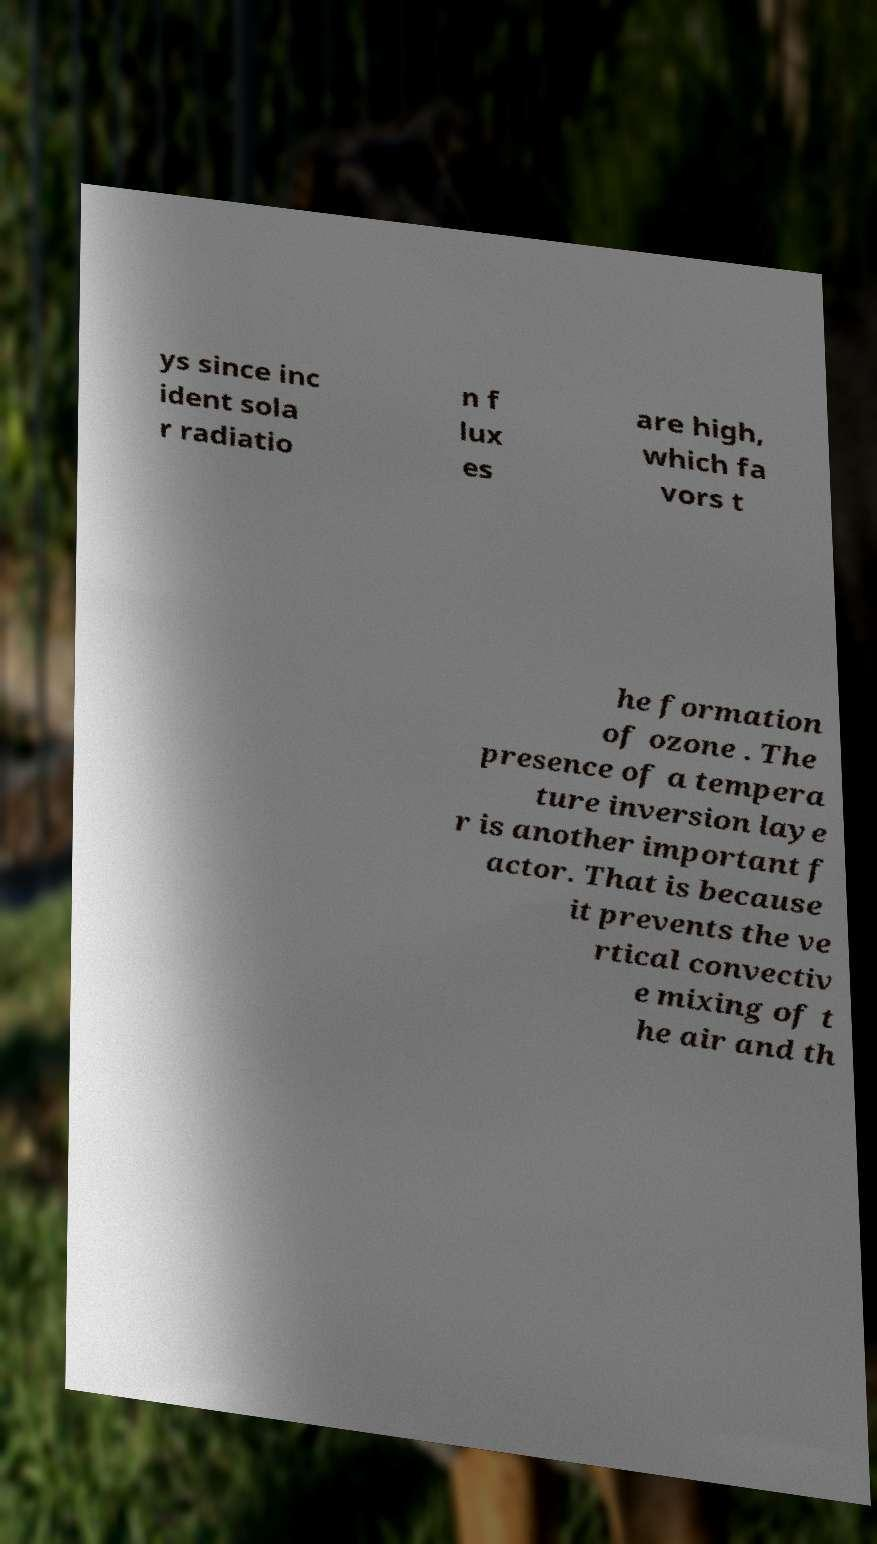Please read and relay the text visible in this image. What does it say? ys since inc ident sola r radiatio n f lux es are high, which fa vors t he formation of ozone . The presence of a tempera ture inversion laye r is another important f actor. That is because it prevents the ve rtical convectiv e mixing of t he air and th 